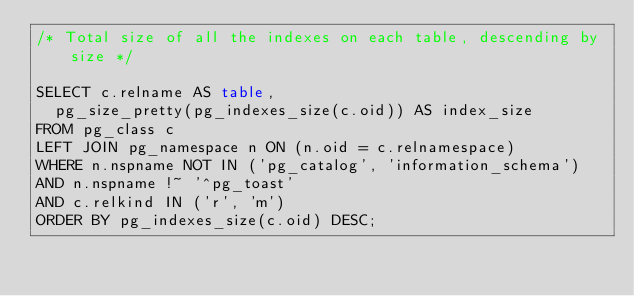<code> <loc_0><loc_0><loc_500><loc_500><_SQL_>/* Total size of all the indexes on each table, descending by size */

SELECT c.relname AS table,
  pg_size_pretty(pg_indexes_size(c.oid)) AS index_size
FROM pg_class c
LEFT JOIN pg_namespace n ON (n.oid = c.relnamespace)
WHERE n.nspname NOT IN ('pg_catalog', 'information_schema')
AND n.nspname !~ '^pg_toast'
AND c.relkind IN ('r', 'm')
ORDER BY pg_indexes_size(c.oid) DESC;
</code> 